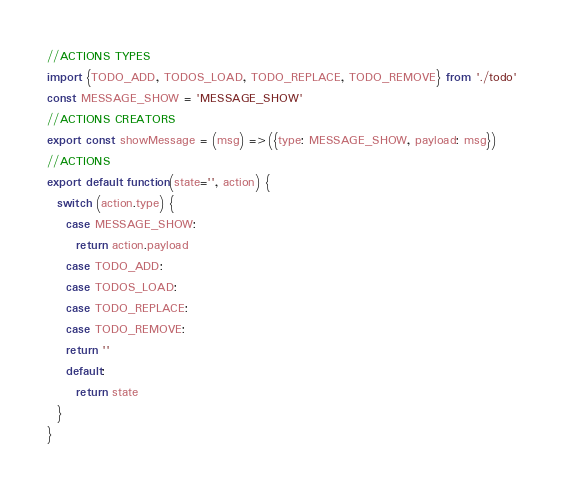<code> <loc_0><loc_0><loc_500><loc_500><_JavaScript_>//ACTIONS TYPES
import {TODO_ADD, TODOS_LOAD, TODO_REPLACE, TODO_REMOVE} from './todo'
const MESSAGE_SHOW = 'MESSAGE_SHOW'
//ACTIONS CREATORS
export const showMessage = (msg) =>({type: MESSAGE_SHOW, payload: msg})
//ACTIONS
export default function(state='', action) {
  switch (action.type) {
    case MESSAGE_SHOW:
      return action.payload
    case TODO_ADD:
    case TODOS_LOAD:
    case TODO_REPLACE:
    case TODO_REMOVE:
    return ''
    default:
      return state
  }
}
</code> 